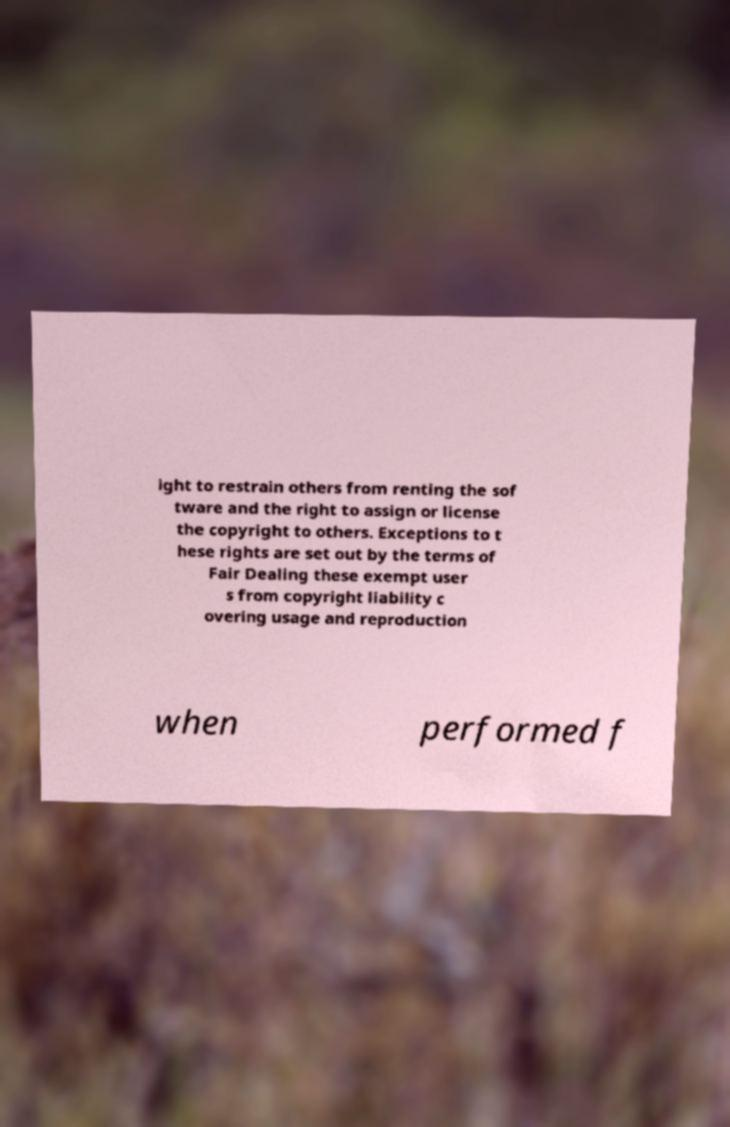Can you accurately transcribe the text from the provided image for me? ight to restrain others from renting the sof tware and the right to assign or license the copyright to others. Exceptions to t hese rights are set out by the terms of Fair Dealing these exempt user s from copyright liability c overing usage and reproduction when performed f 